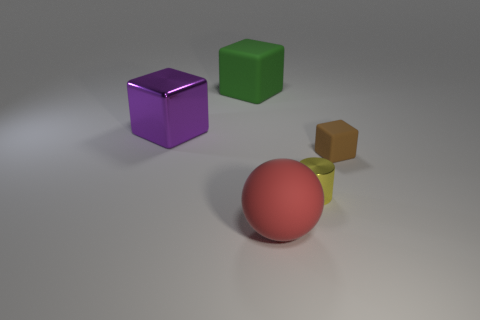Add 4 tiny red metallic cubes. How many objects exist? 9 Subtract all balls. How many objects are left? 4 Add 4 big green blocks. How many big green blocks are left? 5 Add 5 small brown blocks. How many small brown blocks exist? 6 Subtract 0 cyan cylinders. How many objects are left? 5 Subtract all small red matte cylinders. Subtract all green rubber things. How many objects are left? 4 